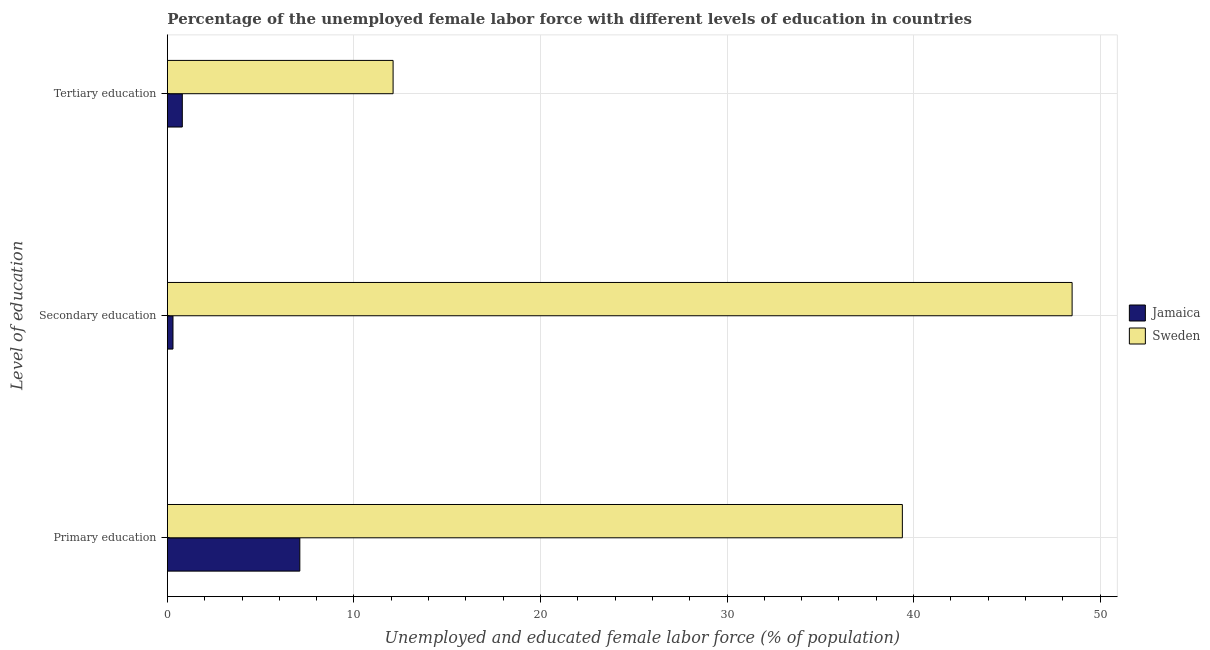How many different coloured bars are there?
Make the answer very short. 2. What is the label of the 3rd group of bars from the top?
Provide a short and direct response. Primary education. What is the percentage of female labor force who received tertiary education in Sweden?
Make the answer very short. 12.1. Across all countries, what is the maximum percentage of female labor force who received secondary education?
Provide a short and direct response. 48.5. Across all countries, what is the minimum percentage of female labor force who received primary education?
Keep it short and to the point. 7.1. In which country was the percentage of female labor force who received tertiary education maximum?
Your answer should be compact. Sweden. In which country was the percentage of female labor force who received tertiary education minimum?
Offer a terse response. Jamaica. What is the total percentage of female labor force who received secondary education in the graph?
Offer a very short reply. 48.8. What is the difference between the percentage of female labor force who received primary education in Jamaica and that in Sweden?
Your response must be concise. -32.3. What is the difference between the percentage of female labor force who received secondary education in Jamaica and the percentage of female labor force who received primary education in Sweden?
Ensure brevity in your answer.  -39.1. What is the average percentage of female labor force who received secondary education per country?
Make the answer very short. 24.4. What is the difference between the percentage of female labor force who received secondary education and percentage of female labor force who received tertiary education in Jamaica?
Ensure brevity in your answer.  -0.5. In how many countries, is the percentage of female labor force who received primary education greater than 38 %?
Ensure brevity in your answer.  1. What is the ratio of the percentage of female labor force who received tertiary education in Sweden to that in Jamaica?
Your answer should be very brief. 15.13. Is the percentage of female labor force who received tertiary education in Sweden less than that in Jamaica?
Your response must be concise. No. Is the difference between the percentage of female labor force who received primary education in Jamaica and Sweden greater than the difference between the percentage of female labor force who received tertiary education in Jamaica and Sweden?
Offer a terse response. No. What is the difference between the highest and the second highest percentage of female labor force who received primary education?
Your answer should be very brief. 32.3. What is the difference between the highest and the lowest percentage of female labor force who received primary education?
Ensure brevity in your answer.  32.3. In how many countries, is the percentage of female labor force who received secondary education greater than the average percentage of female labor force who received secondary education taken over all countries?
Provide a succinct answer. 1. What does the 2nd bar from the top in Tertiary education represents?
Provide a succinct answer. Jamaica. What does the 1st bar from the bottom in Primary education represents?
Offer a terse response. Jamaica. Is it the case that in every country, the sum of the percentage of female labor force who received primary education and percentage of female labor force who received secondary education is greater than the percentage of female labor force who received tertiary education?
Keep it short and to the point. Yes. How many countries are there in the graph?
Provide a succinct answer. 2. What is the difference between two consecutive major ticks on the X-axis?
Provide a short and direct response. 10. Are the values on the major ticks of X-axis written in scientific E-notation?
Your response must be concise. No. Does the graph contain any zero values?
Keep it short and to the point. No. Does the graph contain grids?
Give a very brief answer. Yes. How many legend labels are there?
Provide a succinct answer. 2. What is the title of the graph?
Provide a succinct answer. Percentage of the unemployed female labor force with different levels of education in countries. What is the label or title of the X-axis?
Provide a short and direct response. Unemployed and educated female labor force (% of population). What is the label or title of the Y-axis?
Ensure brevity in your answer.  Level of education. What is the Unemployed and educated female labor force (% of population) in Jamaica in Primary education?
Provide a short and direct response. 7.1. What is the Unemployed and educated female labor force (% of population) of Sweden in Primary education?
Keep it short and to the point. 39.4. What is the Unemployed and educated female labor force (% of population) in Jamaica in Secondary education?
Provide a succinct answer. 0.3. What is the Unemployed and educated female labor force (% of population) in Sweden in Secondary education?
Keep it short and to the point. 48.5. What is the Unemployed and educated female labor force (% of population) of Jamaica in Tertiary education?
Offer a very short reply. 0.8. What is the Unemployed and educated female labor force (% of population) in Sweden in Tertiary education?
Provide a short and direct response. 12.1. Across all Level of education, what is the maximum Unemployed and educated female labor force (% of population) of Jamaica?
Make the answer very short. 7.1. Across all Level of education, what is the maximum Unemployed and educated female labor force (% of population) in Sweden?
Give a very brief answer. 48.5. Across all Level of education, what is the minimum Unemployed and educated female labor force (% of population) of Jamaica?
Keep it short and to the point. 0.3. Across all Level of education, what is the minimum Unemployed and educated female labor force (% of population) in Sweden?
Provide a succinct answer. 12.1. What is the total Unemployed and educated female labor force (% of population) of Sweden in the graph?
Your response must be concise. 100. What is the difference between the Unemployed and educated female labor force (% of population) in Jamaica in Primary education and that in Secondary education?
Your answer should be compact. 6.8. What is the difference between the Unemployed and educated female labor force (% of population) of Jamaica in Primary education and that in Tertiary education?
Your answer should be compact. 6.3. What is the difference between the Unemployed and educated female labor force (% of population) of Sweden in Primary education and that in Tertiary education?
Your response must be concise. 27.3. What is the difference between the Unemployed and educated female labor force (% of population) in Jamaica in Secondary education and that in Tertiary education?
Make the answer very short. -0.5. What is the difference between the Unemployed and educated female labor force (% of population) of Sweden in Secondary education and that in Tertiary education?
Keep it short and to the point. 36.4. What is the difference between the Unemployed and educated female labor force (% of population) in Jamaica in Primary education and the Unemployed and educated female labor force (% of population) in Sweden in Secondary education?
Ensure brevity in your answer.  -41.4. What is the average Unemployed and educated female labor force (% of population) in Jamaica per Level of education?
Provide a succinct answer. 2.73. What is the average Unemployed and educated female labor force (% of population) of Sweden per Level of education?
Your answer should be compact. 33.33. What is the difference between the Unemployed and educated female labor force (% of population) in Jamaica and Unemployed and educated female labor force (% of population) in Sweden in Primary education?
Make the answer very short. -32.3. What is the difference between the Unemployed and educated female labor force (% of population) in Jamaica and Unemployed and educated female labor force (% of population) in Sweden in Secondary education?
Your response must be concise. -48.2. What is the ratio of the Unemployed and educated female labor force (% of population) in Jamaica in Primary education to that in Secondary education?
Your response must be concise. 23.67. What is the ratio of the Unemployed and educated female labor force (% of population) of Sweden in Primary education to that in Secondary education?
Make the answer very short. 0.81. What is the ratio of the Unemployed and educated female labor force (% of population) of Jamaica in Primary education to that in Tertiary education?
Your answer should be very brief. 8.88. What is the ratio of the Unemployed and educated female labor force (% of population) of Sweden in Primary education to that in Tertiary education?
Offer a terse response. 3.26. What is the ratio of the Unemployed and educated female labor force (% of population) of Jamaica in Secondary education to that in Tertiary education?
Your answer should be very brief. 0.38. What is the ratio of the Unemployed and educated female labor force (% of population) of Sweden in Secondary education to that in Tertiary education?
Make the answer very short. 4.01. What is the difference between the highest and the second highest Unemployed and educated female labor force (% of population) of Jamaica?
Your answer should be very brief. 6.3. What is the difference between the highest and the second highest Unemployed and educated female labor force (% of population) in Sweden?
Give a very brief answer. 9.1. What is the difference between the highest and the lowest Unemployed and educated female labor force (% of population) in Jamaica?
Ensure brevity in your answer.  6.8. What is the difference between the highest and the lowest Unemployed and educated female labor force (% of population) in Sweden?
Keep it short and to the point. 36.4. 